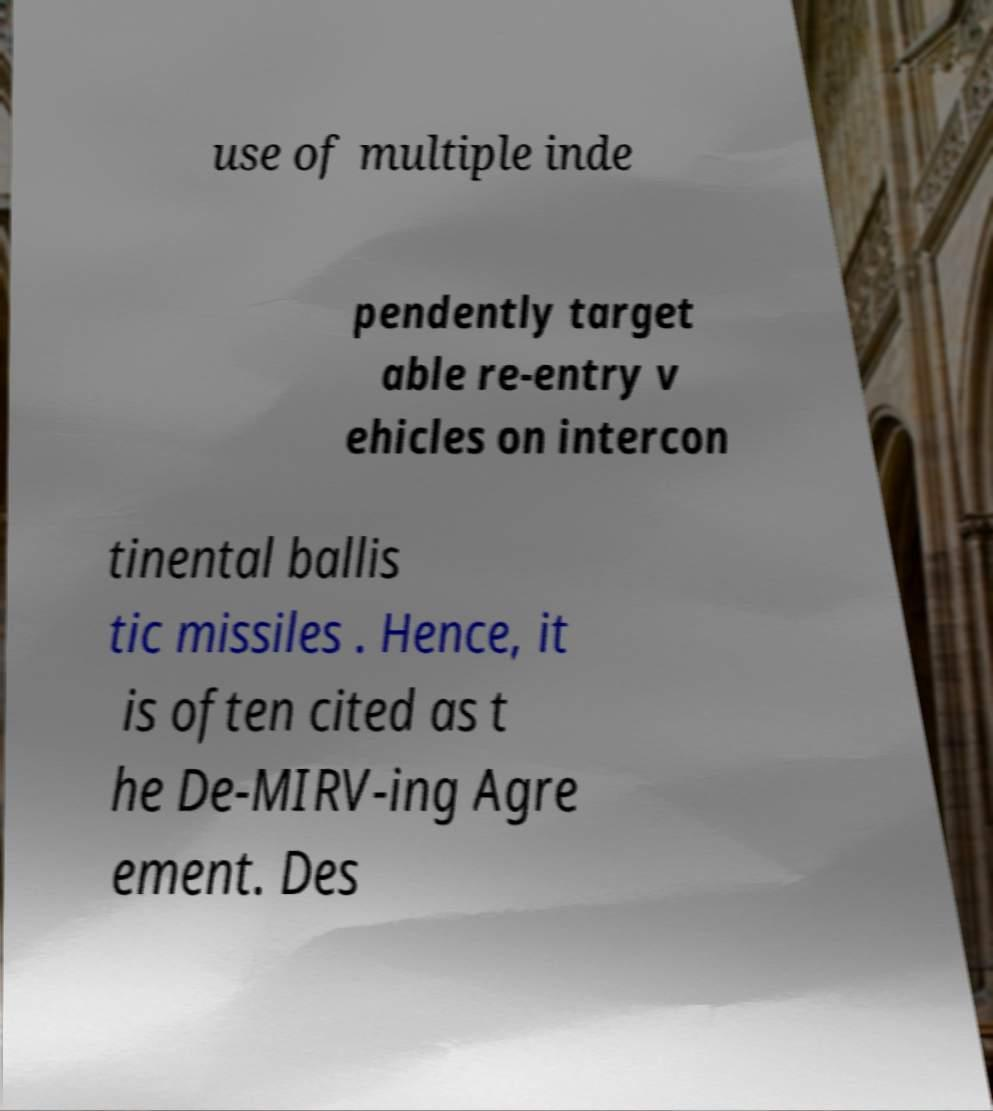There's text embedded in this image that I need extracted. Can you transcribe it verbatim? use of multiple inde pendently target able re-entry v ehicles on intercon tinental ballis tic missiles . Hence, it is often cited as t he De-MIRV-ing Agre ement. Des 